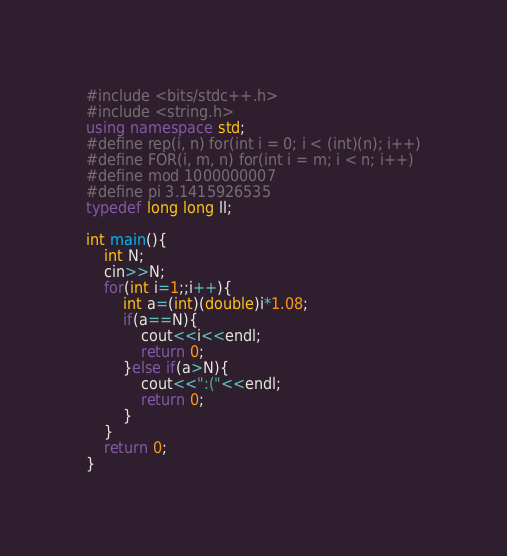Convert code to text. <code><loc_0><loc_0><loc_500><loc_500><_C++_>#include <bits/stdc++.h>
#include <string.h>
using namespace std;
#define rep(i, n) for(int i = 0; i < (int)(n); i++)
#define FOR(i, m, n) for(int i = m; i < n; i++) 
#define mod 1000000007
#define pi 3.1415926535
typedef long long ll;

int main(){
    int N;
    cin>>N;
    for(int i=1;;i++){
        int a=(int)(double)i*1.08;
        if(a==N){
            cout<<i<<endl;
            return 0;
        }else if(a>N){
            cout<<":("<<endl;
            return 0;
        }
    }
    return 0;
}</code> 